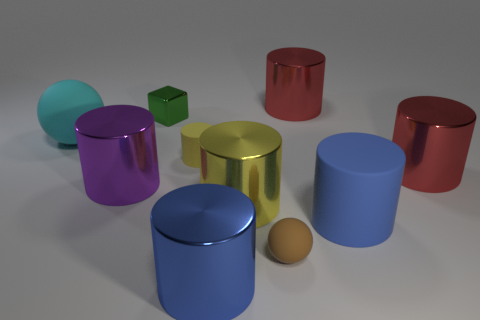There is a matte cylinder that is to the right of the red cylinder left of the matte cylinder to the right of the small yellow thing; what is its color?
Provide a succinct answer. Blue. Is there a purple thing of the same shape as the brown matte object?
Your response must be concise. No. Are there more brown matte balls that are behind the purple object than purple metallic cylinders?
Give a very brief answer. No. How many metallic objects are gray objects or small cylinders?
Provide a succinct answer. 0. There is a thing that is behind the yellow matte cylinder and in front of the small green thing; what is its size?
Make the answer very short. Large. There is a big cylinder to the left of the small yellow cylinder; is there a big yellow cylinder that is in front of it?
Keep it short and to the point. Yes. How many red shiny cylinders are in front of the metallic block?
Your answer should be compact. 1. What color is the other tiny thing that is the same shape as the purple thing?
Offer a terse response. Yellow. Is the material of the cylinder that is behind the cyan thing the same as the tiny object behind the small yellow matte cylinder?
Ensure brevity in your answer.  Yes. Is the color of the block the same as the small rubber object that is behind the big yellow object?
Your response must be concise. No. 